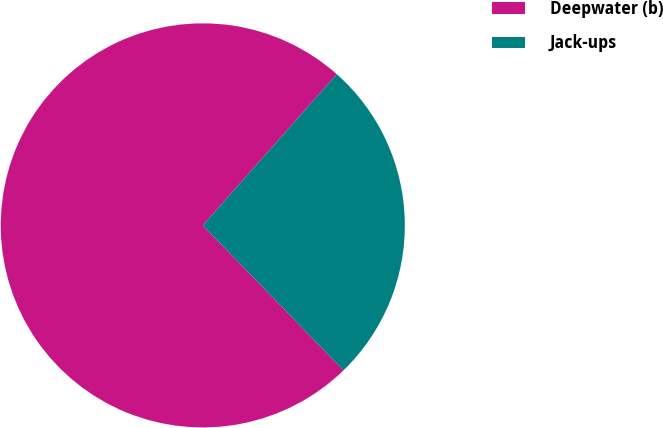Convert chart. <chart><loc_0><loc_0><loc_500><loc_500><pie_chart><fcel>Deepwater (b)<fcel>Jack-ups<nl><fcel>73.81%<fcel>26.19%<nl></chart> 